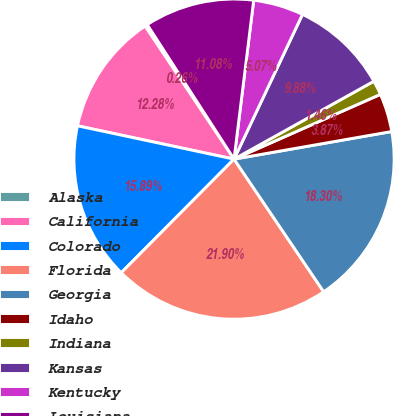Convert chart. <chart><loc_0><loc_0><loc_500><loc_500><pie_chart><fcel>Alaska<fcel>California<fcel>Colorado<fcel>Florida<fcel>Georgia<fcel>Idaho<fcel>Indiana<fcel>Kansas<fcel>Kentucky<fcel>Louisiana<nl><fcel>0.26%<fcel>12.28%<fcel>15.89%<fcel>21.9%<fcel>18.3%<fcel>3.87%<fcel>1.46%<fcel>9.88%<fcel>5.07%<fcel>11.08%<nl></chart> 